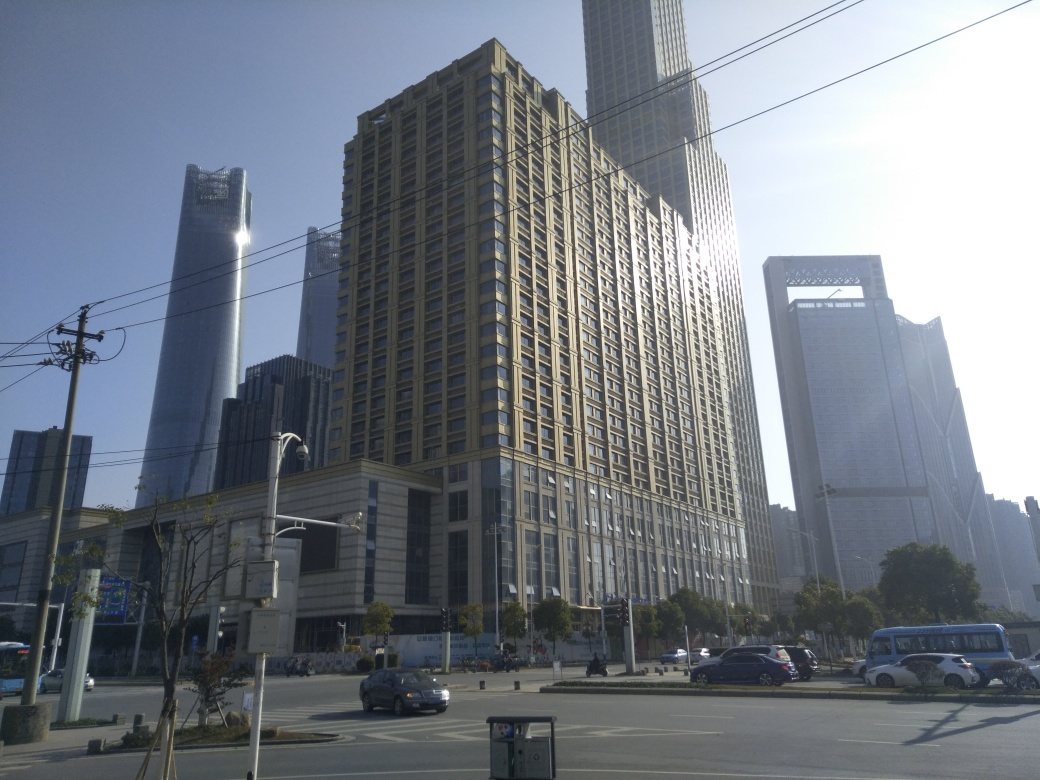Is there any motion blur in the image? Based on the clarity and sharpness of the elements within this urban scene, such as the stationary vehicles, buildings, and street fixtures, there is no discernible motion blur present in the image. Everything appears to be captured with a shutter speed fast enough to prevent blurring. 